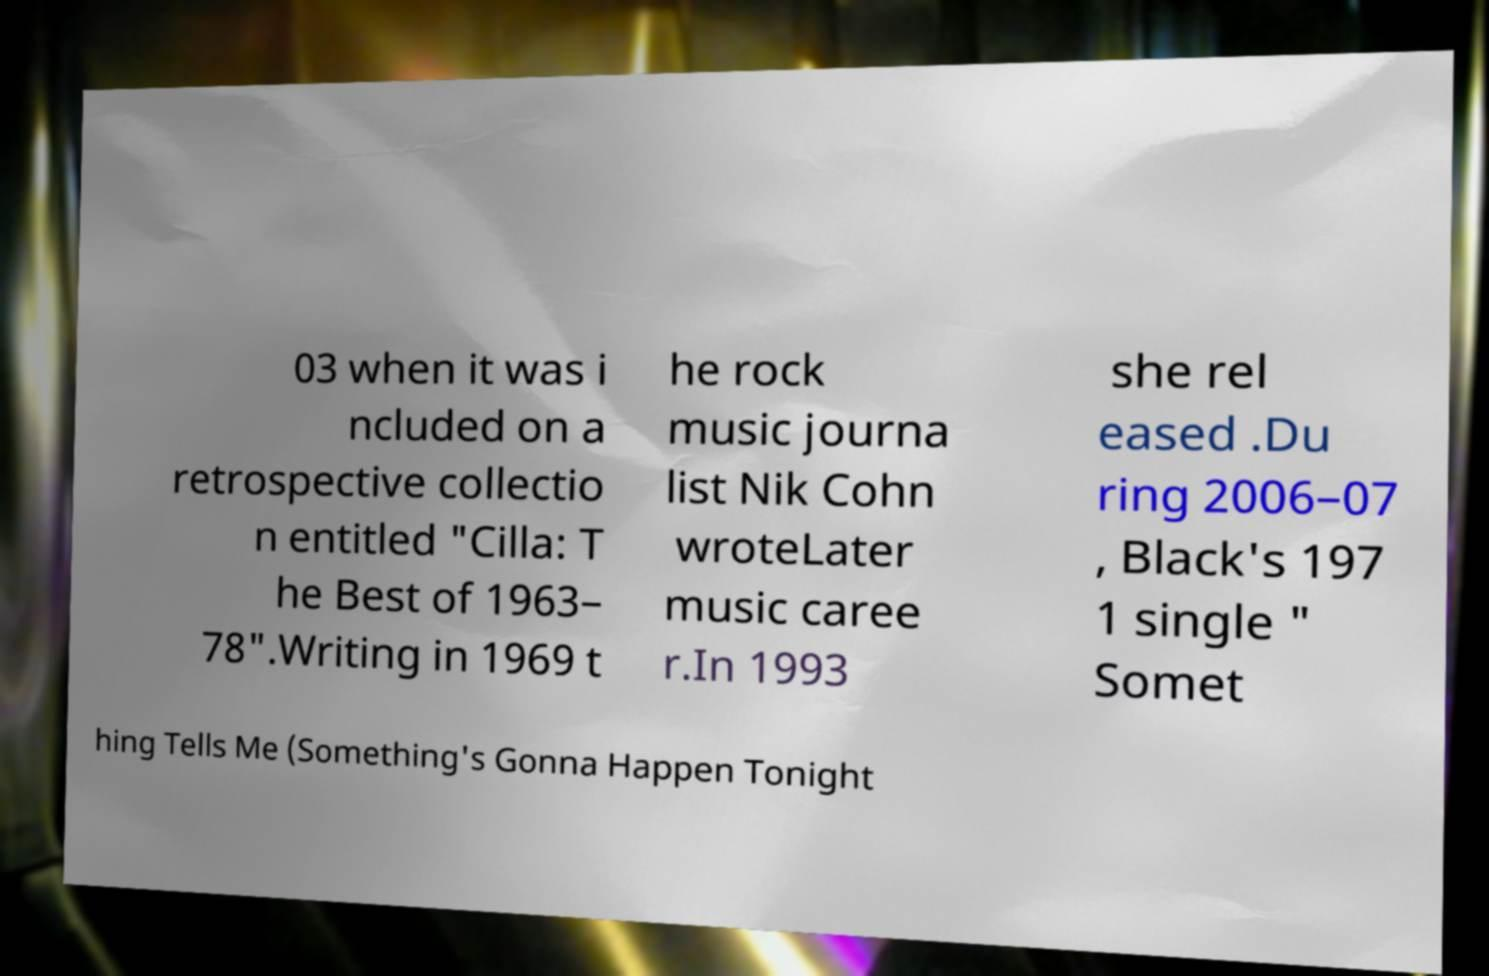Please read and relay the text visible in this image. What does it say? 03 when it was i ncluded on a retrospective collectio n entitled "Cilla: T he Best of 1963– 78".Writing in 1969 t he rock music journa list Nik Cohn wroteLater music caree r.In 1993 she rel eased .Du ring 2006–07 , Black's 197 1 single " Somet hing Tells Me (Something's Gonna Happen Tonight 